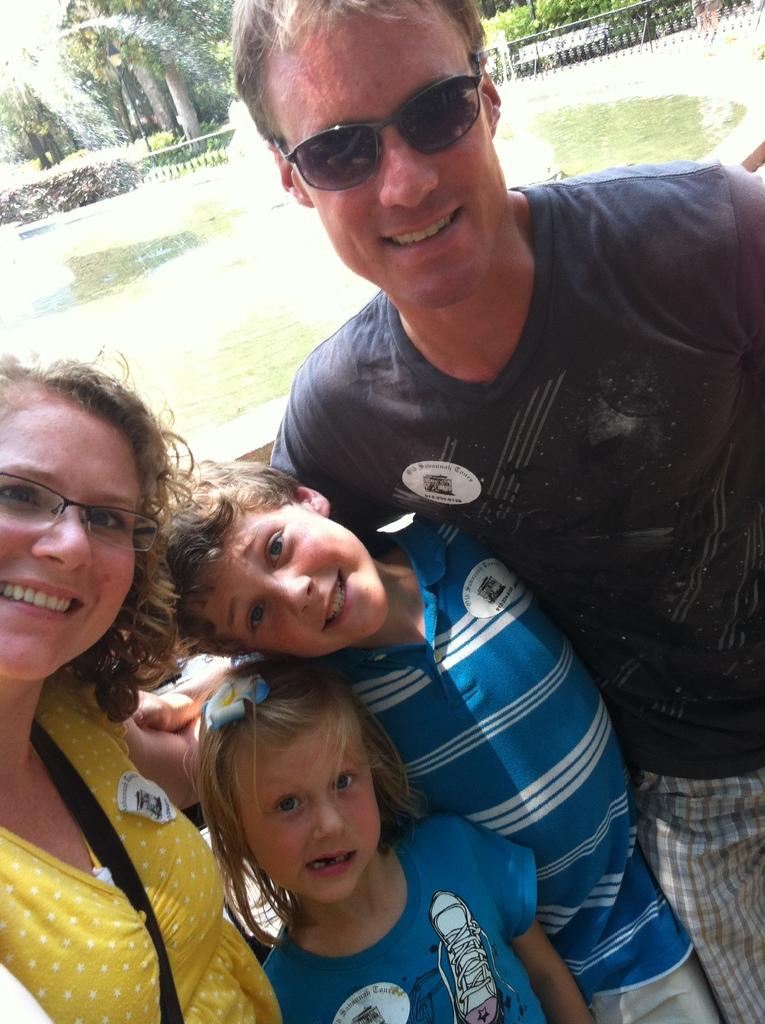How many adults are in the image? There are two adults in the image. How many children are in the image? There are two children in the image. What can be seen in the background of the image? There is a fountain and trees in the background of the image. What type of poison is the man in the image? There is no man present in the image, and therefore no such activity can be observed. 